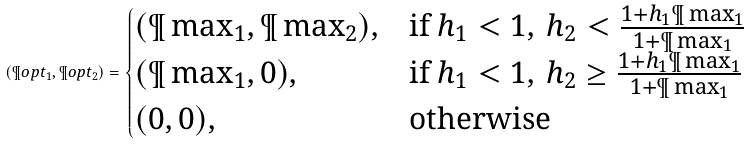Convert formula to latex. <formula><loc_0><loc_0><loc_500><loc_500>( \P o p t _ { 1 } , \P o p t _ { 2 } ) = \begin{cases} ( \P \max _ { 1 } , \P \max _ { 2 } ) , & \text {if } h _ { 1 } < 1 , \, h _ { 2 } < \frac { 1 + h _ { 1 } \P \max _ { 1 } } { 1 + \P \max _ { 1 } } \\ ( \P \max _ { 1 } , 0 ) , & \text {if } h _ { 1 } < 1 , \, h _ { 2 } \geq \frac { 1 + h _ { 1 } \P \max _ { 1 } } { 1 + \P \max _ { 1 } } \\ ( 0 , 0 ) , & \text {otherwise} \end{cases}</formula> 